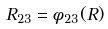Convert formula to latex. <formula><loc_0><loc_0><loc_500><loc_500>R _ { 2 3 } = \phi _ { 2 3 } ( R )</formula> 